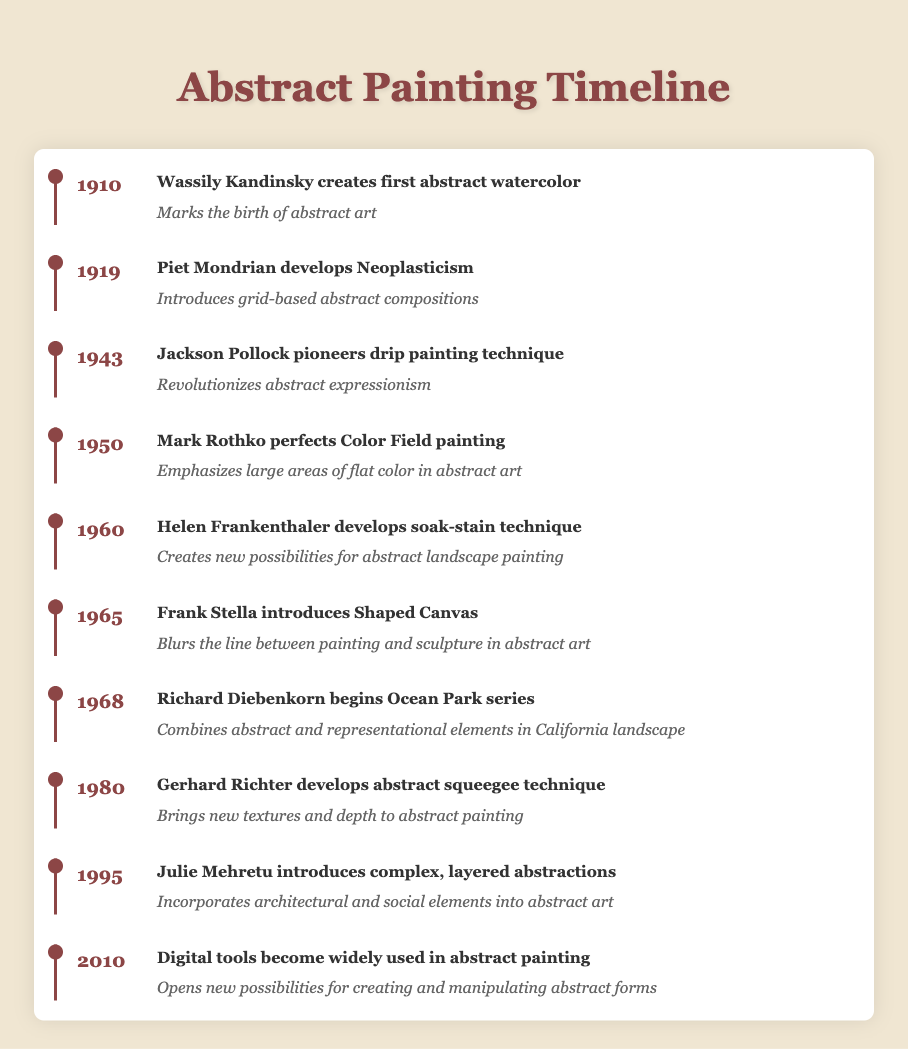What event marks the birth of abstract art in the timeline? The timeline indicates that Wassily Kandinsky created the first abstract watercolor in 1910, which is noted as marking the birth of abstract art.
Answer: Wassily Kandinsky creates first abstract watercolor Which artist is associated with the development of Neoplasticism? According to the timeline, the artist Piet Mondrian is specifically mentioned as the one who developed Neoplasticism in 1919.
Answer: Piet Mondrian What year did Jackson Pollock pioneer the drip painting technique? The event notes that Jackson Pollock pioneered the drip painting technique in 1943, which is explicitly stated in the timeline.
Answer: 1943 Is it true that Helen Frankenthaler developed the soak-stain technique? The timeline confirms that Helen Frankenthaler indeed developed the soak-stain technique in 1960, making this statement true.
Answer: Yes What is the significance of Mark Rothko's Color Field painting? The timeline specifies that Mark Rothko's innovation emphasizes large areas of flat color in abstract art, highlighting its significance in this context.
Answer: Emphasizes large areas of flat color in abstract art Which two artists introduced techniques that blurred the line between painting and other forms? The timeline indicates that both Frank Stella, with the Shaped Canvas in 1965, and Jackson Pollock, with drip painting in 1943, contributed techniques that blurred the line between painting and other forms. Both events are needed for a complete answer.
Answer: Frank Stella and Jackson Pollock In which decade did digital tools become widely used for abstract painting? The timeline clearly states that digital tools became widely used in abstract painting in 2010, which is in the last decade of the timeline.
Answer: 2010 How many years passed between Richard Diebenkorn's start of the Ocean Park series and Julie Mehretu's introduction of complex abstractions? Richard Diebenkorn began the Ocean Park series in 1968, and Julie Mehretu introduced complex abstractions in 1995. The difference is 1995 - 1968 = 27 years.
Answer: 27 years Which event introduced grid-based abstract compositions? The timeline indicates that Piet Mondrian’s development of Neoplasticism in 1919 introduced grid-based abstract compositions.
Answer: Piet Mondrian develops Neoplasticism 